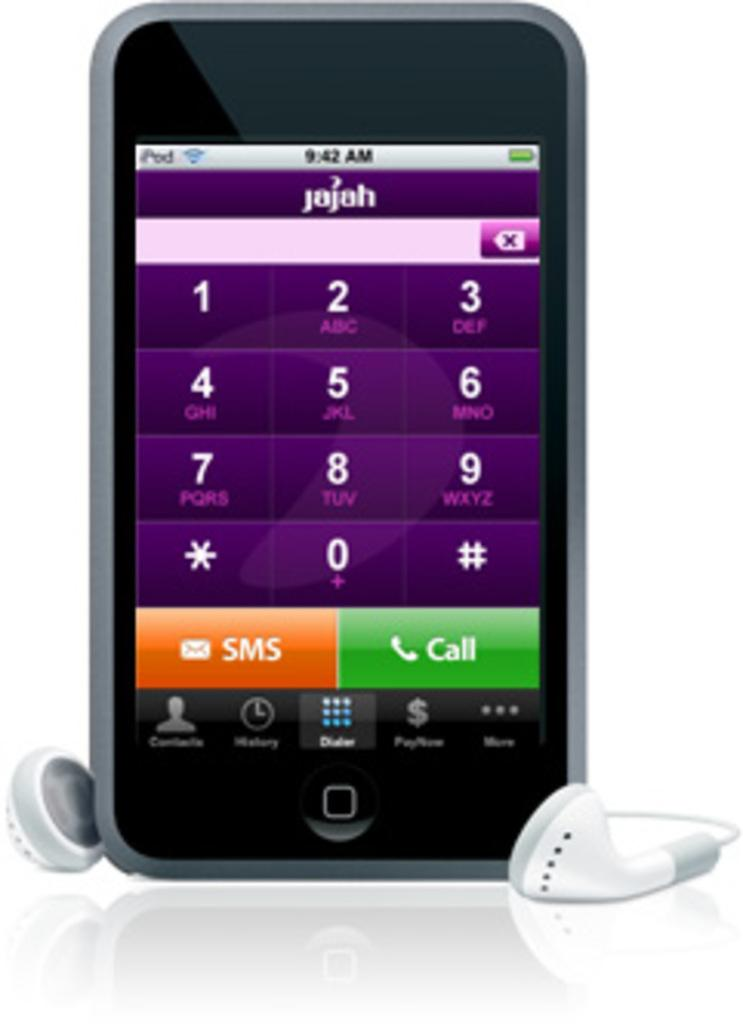<image>
Present a compact description of the photo's key features. A phone with rajah at the top and the time is 9:42 AM 